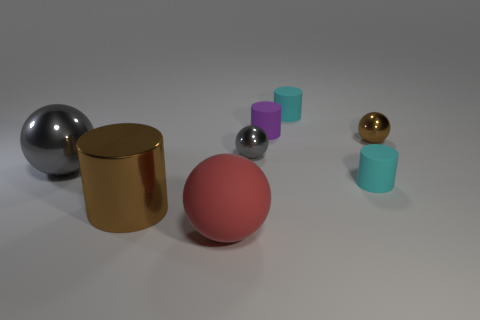How many brown spheres are there?
Keep it short and to the point. 1. There is a gray thing that is the same size as the shiny cylinder; what is its material?
Give a very brief answer. Metal. Is there a blue rubber block of the same size as the red rubber object?
Your answer should be very brief. No. Does the shiny ball that is left of the big brown cylinder have the same color as the small sphere left of the brown metal sphere?
Offer a terse response. Yes. What number of shiny things are either yellow cubes or red balls?
Offer a very short reply. 0. There is a matte cylinder in front of the big ball that is behind the big brown thing; how many brown things are behind it?
Provide a short and direct response. 1. What is the size of the cylinder that is the same material as the small brown thing?
Your answer should be compact. Large. How many tiny metallic objects have the same color as the large rubber sphere?
Offer a terse response. 0. Do the cyan rubber cylinder behind the purple matte cylinder and the red object have the same size?
Provide a short and direct response. No. There is a big thing that is to the right of the big gray shiny thing and behind the rubber sphere; what is its color?
Offer a terse response. Brown. 